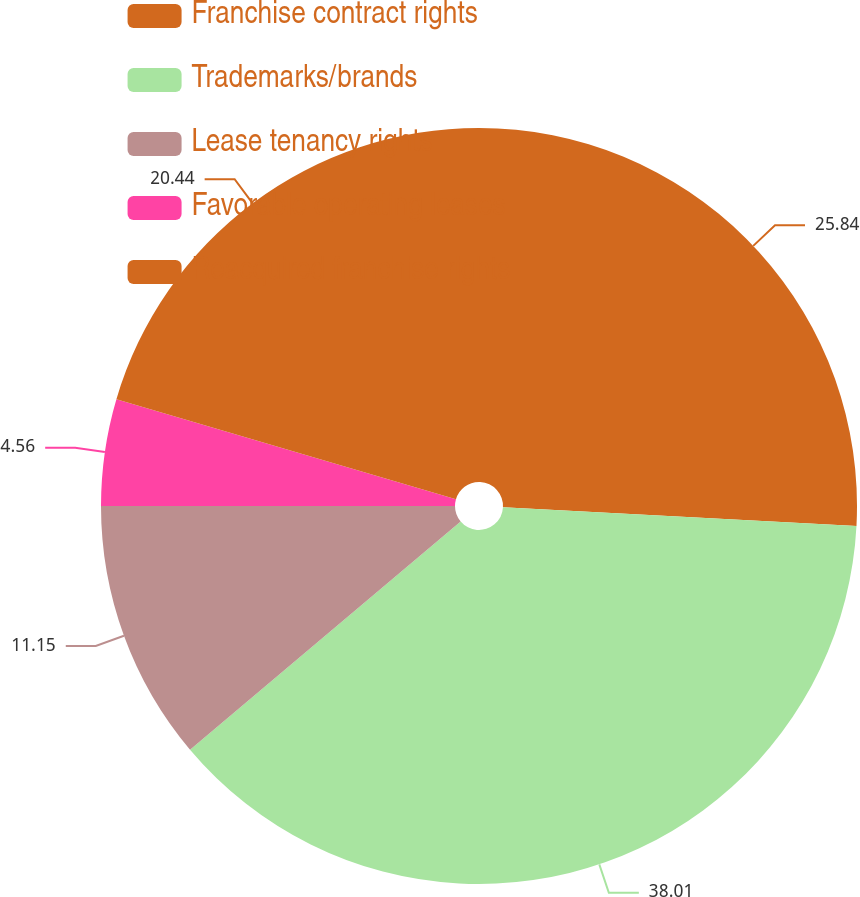<chart> <loc_0><loc_0><loc_500><loc_500><pie_chart><fcel>Franchise contract rights<fcel>Trademarks/brands<fcel>Lease tenancy rights<fcel>Favorable operating leases<fcel>Reacquired franchise rights<nl><fcel>25.84%<fcel>38.01%<fcel>11.15%<fcel>4.56%<fcel>20.44%<nl></chart> 